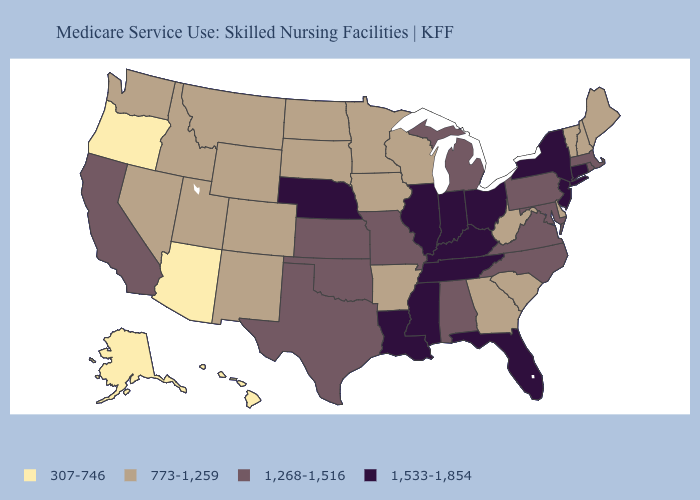Which states hav the highest value in the Northeast?
Keep it brief. Connecticut, New Jersey, New York. Which states have the lowest value in the Northeast?
Give a very brief answer. Maine, New Hampshire, Vermont. What is the value of Massachusetts?
Answer briefly. 1,268-1,516. Name the states that have a value in the range 773-1,259?
Write a very short answer. Arkansas, Colorado, Delaware, Georgia, Idaho, Iowa, Maine, Minnesota, Montana, Nevada, New Hampshire, New Mexico, North Dakota, South Carolina, South Dakota, Utah, Vermont, Washington, West Virginia, Wisconsin, Wyoming. Name the states that have a value in the range 307-746?
Answer briefly. Alaska, Arizona, Hawaii, Oregon. Does California have the highest value in the West?
Keep it brief. Yes. Name the states that have a value in the range 1,533-1,854?
Quick response, please. Connecticut, Florida, Illinois, Indiana, Kentucky, Louisiana, Mississippi, Nebraska, New Jersey, New York, Ohio, Tennessee. Does the first symbol in the legend represent the smallest category?
Keep it brief. Yes. Name the states that have a value in the range 1,268-1,516?
Keep it brief. Alabama, California, Kansas, Maryland, Massachusetts, Michigan, Missouri, North Carolina, Oklahoma, Pennsylvania, Rhode Island, Texas, Virginia. Does Washington have the same value as Arkansas?
Answer briefly. Yes. Does Florida have the highest value in the USA?
Short answer required. Yes. Name the states that have a value in the range 1,268-1,516?
Be succinct. Alabama, California, Kansas, Maryland, Massachusetts, Michigan, Missouri, North Carolina, Oklahoma, Pennsylvania, Rhode Island, Texas, Virginia. What is the value of New Hampshire?
Write a very short answer. 773-1,259. What is the highest value in the USA?
Quick response, please. 1,533-1,854. 